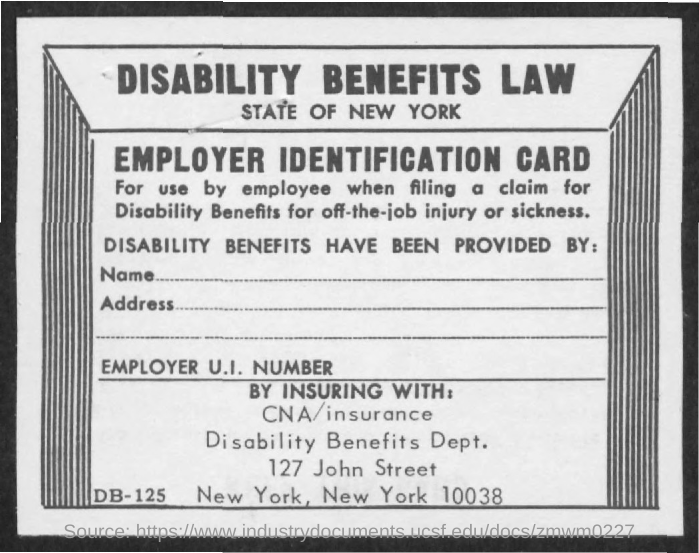Whats the title of page?
Your answer should be very brief. Disability benefits law. 